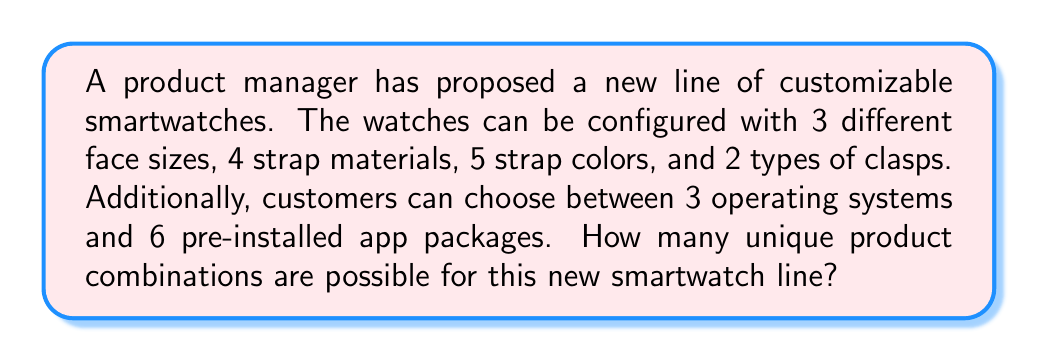Help me with this question. To calculate the total number of possible product combinations, we need to use the multiplication principle of counting. This principle states that if we have independent choices, we multiply the number of options for each choice to get the total number of possibilities.

Let's break down the choices:
1. Face sizes: 3 options
2. Strap materials: 4 options
3. Strap colors: 5 options
4. Clasp types: 2 options
5. Operating systems: 3 options
6. Pre-installed app packages: 6 options

To find the total number of combinations, we multiply these numbers:

$$ \text{Total combinations} = 3 \times 4 \times 5 \times 2 \times 3 \times 6 $$

Calculating this:
$$ \text{Total combinations} = 3 \times 4 \times 5 \times 2 \times 3 \times 6 = 2,160 $$

Therefore, there are 2,160 possible unique product combinations for the new smartwatch line.
Answer: 2,160 combinations 